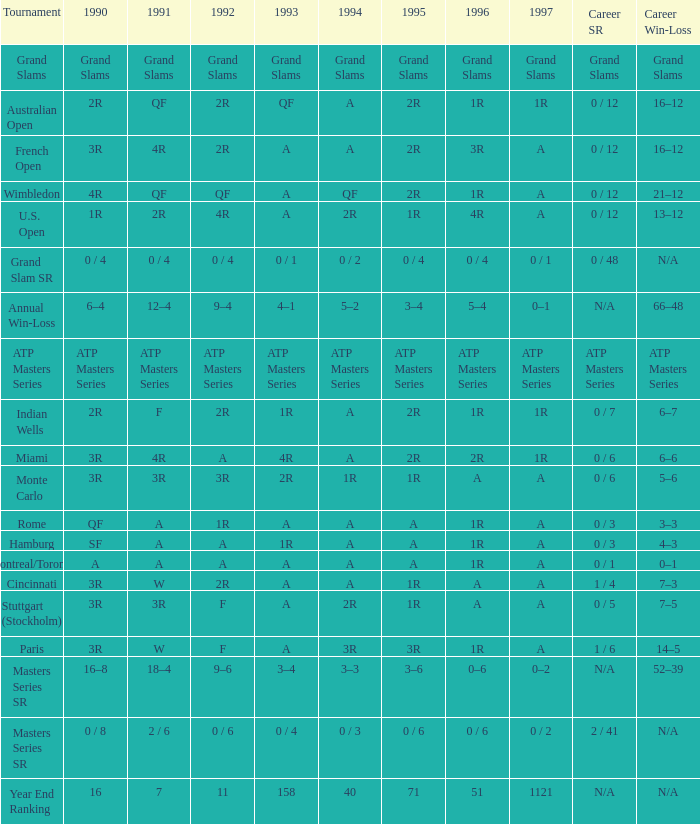What is 1994, when 1991 is "qf", and when competition is "australian open"? A. 